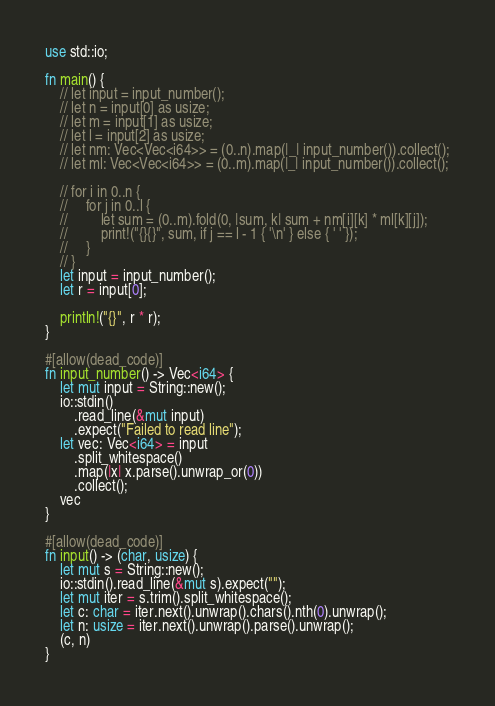Convert code to text. <code><loc_0><loc_0><loc_500><loc_500><_Rust_>use std::io;

fn main() {
    // let input = input_number();
    // let n = input[0] as usize;
    // let m = input[1] as usize;
    // let l = input[2] as usize;
    // let nm: Vec<Vec<i64>> = (0..n).map(|_| input_number()).collect();
    // let ml: Vec<Vec<i64>> = (0..m).map(|_| input_number()).collect();

    // for i in 0..n {
    //     for j in 0..l {
    //         let sum = (0..m).fold(0, |sum, k| sum + nm[i][k] * ml[k][j]);
    //         print!("{}{}", sum, if j == l - 1 { '\n' } else { ' ' });
    //     }
    // }
    let input = input_number();
    let r = input[0];

    println!("{}", r * r);
}

#[allow(dead_code)]
fn input_number() -> Vec<i64> {
    let mut input = String::new();
    io::stdin()
        .read_line(&mut input)
        .expect("Failed to read line");
    let vec: Vec<i64> = input
        .split_whitespace()
        .map(|x| x.parse().unwrap_or(0))
        .collect();
    vec
}

#[allow(dead_code)]
fn input() -> (char, usize) {
    let mut s = String::new();
    io::stdin().read_line(&mut s).expect("");
    let mut iter = s.trim().split_whitespace();
    let c: char = iter.next().unwrap().chars().nth(0).unwrap();
    let n: usize = iter.next().unwrap().parse().unwrap();
    (c, n)
}
</code> 